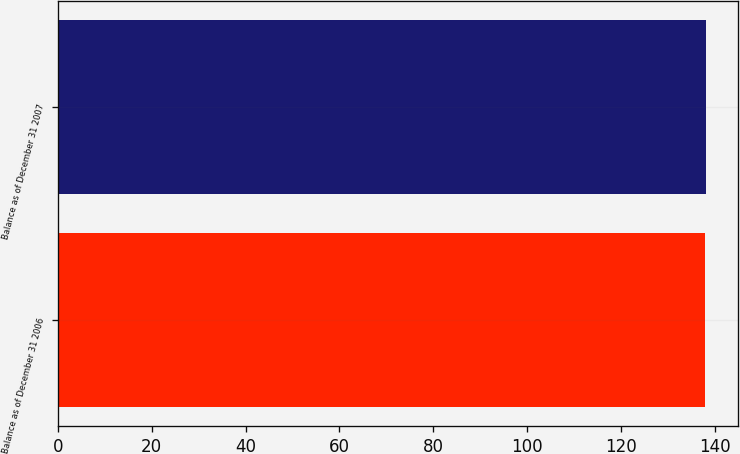Convert chart. <chart><loc_0><loc_0><loc_500><loc_500><bar_chart><fcel>Balance as of December 31 2006<fcel>Balance as of December 31 2007<nl><fcel>138<fcel>138.1<nl></chart> 